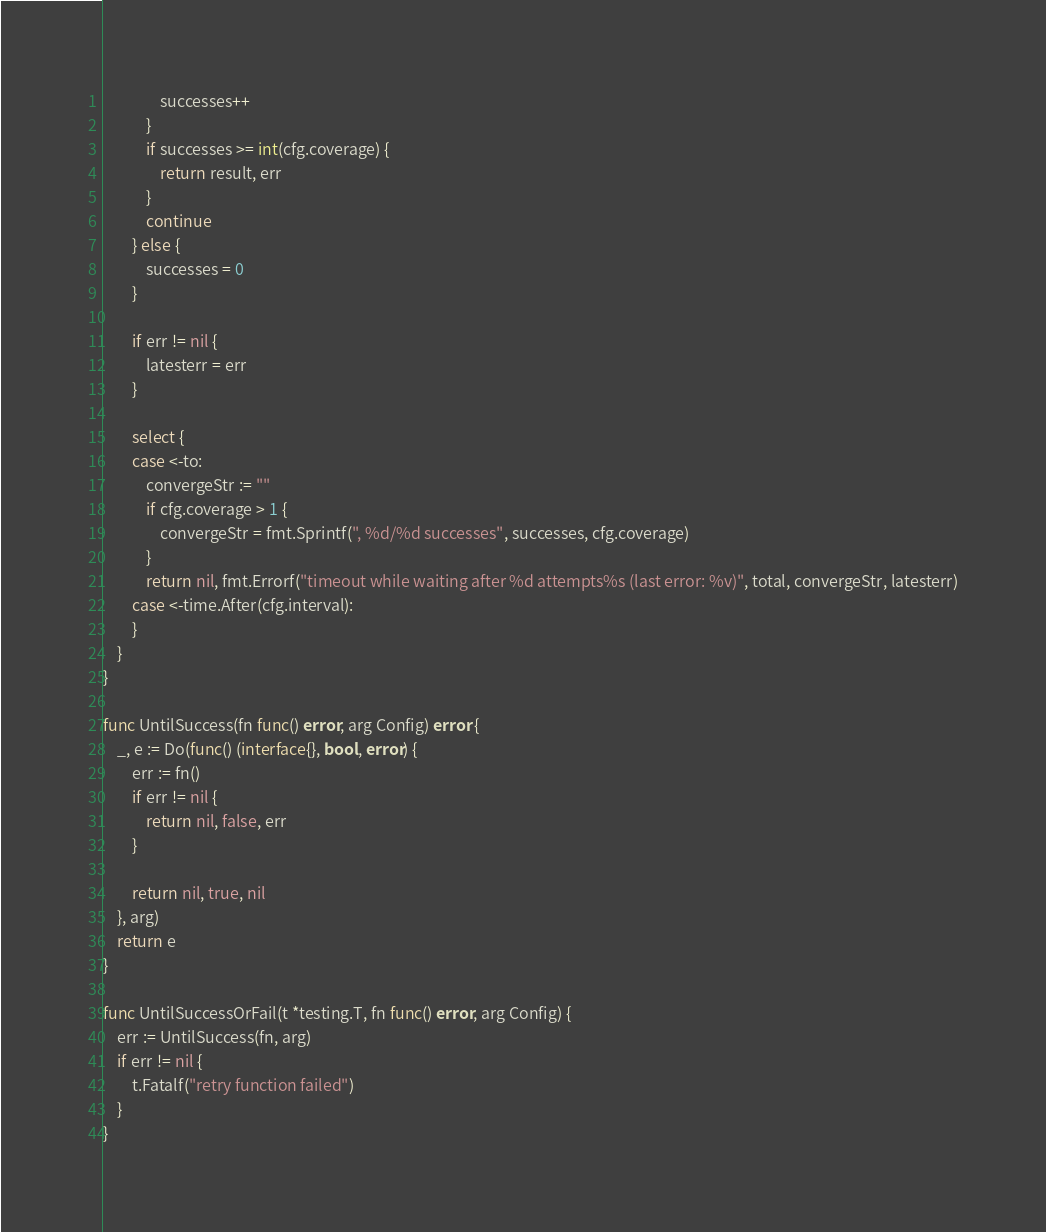<code> <loc_0><loc_0><loc_500><loc_500><_Go_>				successes++
			}
			if successes >= int(cfg.coverage) {
				return result, err
			}
			continue
		} else {
			successes = 0
		}

		if err != nil {
			latesterr = err
		}

		select {
		case <-to:
			convergeStr := ""
			if cfg.coverage > 1 {
				convergeStr = fmt.Sprintf(", %d/%d successes", successes, cfg.coverage)
			}
			return nil, fmt.Errorf("timeout while waiting after %d attempts%s (last error: %v)", total, convergeStr, latesterr)
		case <-time.After(cfg.interval):
		}
	}
}

func UntilSuccess(fn func() error, arg Config) error {
	_, e := Do(func() (interface{}, bool, error) {
		err := fn()
		if err != nil {
			return nil, false, err
		}

		return nil, true, nil
	}, arg)
	return e
}

func UntilSuccessOrFail(t *testing.T, fn func() error, arg Config) {
	err := UntilSuccess(fn, arg)
	if err != nil {
		t.Fatalf("retry function failed")
	}
}
</code> 